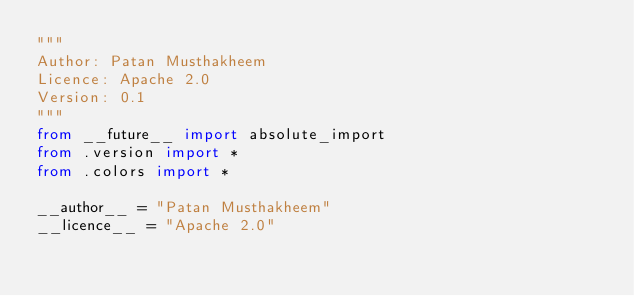<code> <loc_0><loc_0><loc_500><loc_500><_Python_>"""
Author: Patan Musthakheem
Licence: Apache 2.0
Version: 0.1
"""
from __future__ import absolute_import
from .version import *
from .colors import *

__author__ = "Patan Musthakheem"
__licence__ = "Apache 2.0"
</code> 